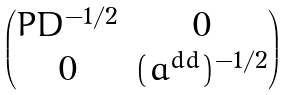Convert formula to latex. <formula><loc_0><loc_0><loc_500><loc_500>\begin{pmatrix} P D ^ { - 1 / 2 } & 0 \\ 0 & ( a ^ { d d } ) ^ { - 1 / 2 } \end{pmatrix}</formula> 